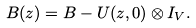Convert formula to latex. <formula><loc_0><loc_0><loc_500><loc_500>B ( z ) = B - U ( z , 0 ) \otimes I _ { V } .</formula> 